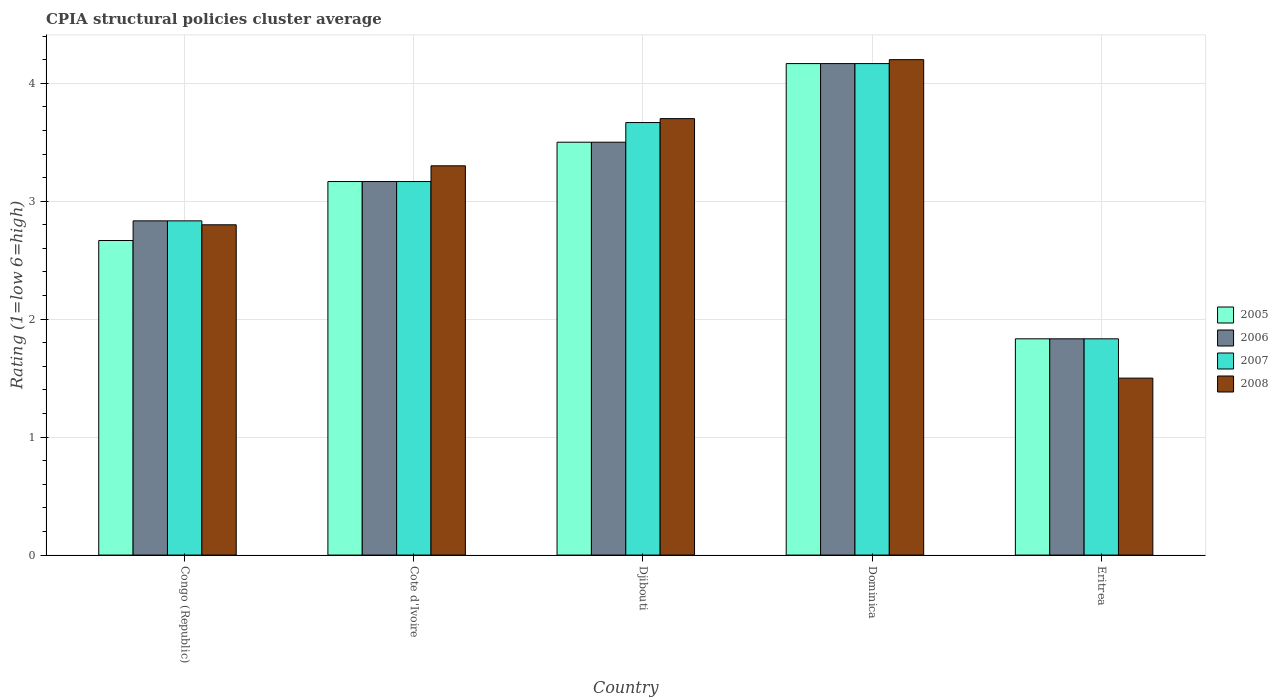How many different coloured bars are there?
Offer a very short reply. 4. Are the number of bars on each tick of the X-axis equal?
Provide a short and direct response. Yes. How many bars are there on the 4th tick from the right?
Offer a terse response. 4. What is the label of the 2nd group of bars from the left?
Your answer should be compact. Cote d'Ivoire. In how many cases, is the number of bars for a given country not equal to the number of legend labels?
Your answer should be very brief. 0. What is the CPIA rating in 2006 in Congo (Republic)?
Your response must be concise. 2.83. Across all countries, what is the minimum CPIA rating in 2006?
Your answer should be very brief. 1.83. In which country was the CPIA rating in 2008 maximum?
Provide a succinct answer. Dominica. In which country was the CPIA rating in 2005 minimum?
Keep it short and to the point. Eritrea. What is the total CPIA rating in 2007 in the graph?
Your response must be concise. 15.67. What is the difference between the CPIA rating in 2007 in Djibouti and that in Dominica?
Ensure brevity in your answer.  -0.5. What is the difference between the CPIA rating in 2006 in Dominica and the CPIA rating in 2005 in Djibouti?
Make the answer very short. 0.67. What is the average CPIA rating in 2008 per country?
Offer a very short reply. 3.1. What is the difference between the CPIA rating of/in 2007 and CPIA rating of/in 2008 in Congo (Republic)?
Ensure brevity in your answer.  0.03. In how many countries, is the CPIA rating in 2005 greater than 4.2?
Make the answer very short. 0. What is the ratio of the CPIA rating in 2008 in Cote d'Ivoire to that in Eritrea?
Keep it short and to the point. 2.2. Is the CPIA rating in 2007 in Congo (Republic) less than that in Djibouti?
Your response must be concise. Yes. What is the difference between the highest and the second highest CPIA rating in 2008?
Provide a short and direct response. -0.4. What is the difference between the highest and the lowest CPIA rating in 2006?
Give a very brief answer. 2.33. In how many countries, is the CPIA rating in 2008 greater than the average CPIA rating in 2008 taken over all countries?
Your response must be concise. 3. Is the sum of the CPIA rating in 2005 in Cote d'Ivoire and Djibouti greater than the maximum CPIA rating in 2006 across all countries?
Provide a succinct answer. Yes. Is it the case that in every country, the sum of the CPIA rating in 2007 and CPIA rating in 2005 is greater than the sum of CPIA rating in 2008 and CPIA rating in 2006?
Provide a short and direct response. No. How many bars are there?
Your answer should be compact. 20. How many countries are there in the graph?
Offer a very short reply. 5. Does the graph contain any zero values?
Keep it short and to the point. No. Does the graph contain grids?
Provide a succinct answer. Yes. What is the title of the graph?
Provide a short and direct response. CPIA structural policies cluster average. Does "2012" appear as one of the legend labels in the graph?
Provide a succinct answer. No. What is the label or title of the X-axis?
Your answer should be compact. Country. What is the label or title of the Y-axis?
Give a very brief answer. Rating (1=low 6=high). What is the Rating (1=low 6=high) in 2005 in Congo (Republic)?
Ensure brevity in your answer.  2.67. What is the Rating (1=low 6=high) in 2006 in Congo (Republic)?
Offer a very short reply. 2.83. What is the Rating (1=low 6=high) in 2007 in Congo (Republic)?
Make the answer very short. 2.83. What is the Rating (1=low 6=high) in 2008 in Congo (Republic)?
Your answer should be very brief. 2.8. What is the Rating (1=low 6=high) in 2005 in Cote d'Ivoire?
Offer a terse response. 3.17. What is the Rating (1=low 6=high) of 2006 in Cote d'Ivoire?
Provide a succinct answer. 3.17. What is the Rating (1=low 6=high) in 2007 in Cote d'Ivoire?
Your answer should be compact. 3.17. What is the Rating (1=low 6=high) in 2005 in Djibouti?
Ensure brevity in your answer.  3.5. What is the Rating (1=low 6=high) of 2006 in Djibouti?
Your response must be concise. 3.5. What is the Rating (1=low 6=high) in 2007 in Djibouti?
Offer a very short reply. 3.67. What is the Rating (1=low 6=high) in 2005 in Dominica?
Provide a short and direct response. 4.17. What is the Rating (1=low 6=high) in 2006 in Dominica?
Offer a terse response. 4.17. What is the Rating (1=low 6=high) of 2007 in Dominica?
Your response must be concise. 4.17. What is the Rating (1=low 6=high) in 2005 in Eritrea?
Your answer should be compact. 1.83. What is the Rating (1=low 6=high) of 2006 in Eritrea?
Your answer should be compact. 1.83. What is the Rating (1=low 6=high) of 2007 in Eritrea?
Ensure brevity in your answer.  1.83. Across all countries, what is the maximum Rating (1=low 6=high) of 2005?
Your response must be concise. 4.17. Across all countries, what is the maximum Rating (1=low 6=high) of 2006?
Provide a short and direct response. 4.17. Across all countries, what is the maximum Rating (1=low 6=high) in 2007?
Ensure brevity in your answer.  4.17. Across all countries, what is the maximum Rating (1=low 6=high) in 2008?
Provide a succinct answer. 4.2. Across all countries, what is the minimum Rating (1=low 6=high) of 2005?
Provide a short and direct response. 1.83. Across all countries, what is the minimum Rating (1=low 6=high) of 2006?
Your answer should be very brief. 1.83. Across all countries, what is the minimum Rating (1=low 6=high) in 2007?
Offer a very short reply. 1.83. What is the total Rating (1=low 6=high) of 2005 in the graph?
Your answer should be compact. 15.33. What is the total Rating (1=low 6=high) in 2006 in the graph?
Your response must be concise. 15.5. What is the total Rating (1=low 6=high) in 2007 in the graph?
Offer a terse response. 15.67. What is the difference between the Rating (1=low 6=high) in 2005 in Congo (Republic) and that in Cote d'Ivoire?
Your response must be concise. -0.5. What is the difference between the Rating (1=low 6=high) in 2006 in Congo (Republic) and that in Djibouti?
Your answer should be compact. -0.67. What is the difference between the Rating (1=low 6=high) of 2008 in Congo (Republic) and that in Djibouti?
Keep it short and to the point. -0.9. What is the difference between the Rating (1=low 6=high) in 2005 in Congo (Republic) and that in Dominica?
Keep it short and to the point. -1.5. What is the difference between the Rating (1=low 6=high) in 2006 in Congo (Republic) and that in Dominica?
Provide a succinct answer. -1.33. What is the difference between the Rating (1=low 6=high) in 2007 in Congo (Republic) and that in Dominica?
Offer a very short reply. -1.33. What is the difference between the Rating (1=low 6=high) in 2005 in Congo (Republic) and that in Eritrea?
Offer a very short reply. 0.83. What is the difference between the Rating (1=low 6=high) in 2006 in Congo (Republic) and that in Eritrea?
Your answer should be compact. 1. What is the difference between the Rating (1=low 6=high) in 2005 in Cote d'Ivoire and that in Dominica?
Provide a short and direct response. -1. What is the difference between the Rating (1=low 6=high) in 2005 in Cote d'Ivoire and that in Eritrea?
Offer a very short reply. 1.33. What is the difference between the Rating (1=low 6=high) of 2006 in Cote d'Ivoire and that in Eritrea?
Provide a succinct answer. 1.33. What is the difference between the Rating (1=low 6=high) in 2008 in Cote d'Ivoire and that in Eritrea?
Ensure brevity in your answer.  1.8. What is the difference between the Rating (1=low 6=high) in 2007 in Djibouti and that in Dominica?
Ensure brevity in your answer.  -0.5. What is the difference between the Rating (1=low 6=high) in 2007 in Djibouti and that in Eritrea?
Make the answer very short. 1.83. What is the difference between the Rating (1=low 6=high) in 2005 in Dominica and that in Eritrea?
Your answer should be compact. 2.33. What is the difference between the Rating (1=low 6=high) in 2006 in Dominica and that in Eritrea?
Your answer should be compact. 2.33. What is the difference between the Rating (1=low 6=high) in 2007 in Dominica and that in Eritrea?
Offer a terse response. 2.33. What is the difference between the Rating (1=low 6=high) in 2008 in Dominica and that in Eritrea?
Your answer should be very brief. 2.7. What is the difference between the Rating (1=low 6=high) of 2005 in Congo (Republic) and the Rating (1=low 6=high) of 2006 in Cote d'Ivoire?
Provide a succinct answer. -0.5. What is the difference between the Rating (1=low 6=high) of 2005 in Congo (Republic) and the Rating (1=low 6=high) of 2007 in Cote d'Ivoire?
Give a very brief answer. -0.5. What is the difference between the Rating (1=low 6=high) in 2005 in Congo (Republic) and the Rating (1=low 6=high) in 2008 in Cote d'Ivoire?
Your response must be concise. -0.63. What is the difference between the Rating (1=low 6=high) of 2006 in Congo (Republic) and the Rating (1=low 6=high) of 2008 in Cote d'Ivoire?
Keep it short and to the point. -0.47. What is the difference between the Rating (1=low 6=high) of 2007 in Congo (Republic) and the Rating (1=low 6=high) of 2008 in Cote d'Ivoire?
Offer a very short reply. -0.47. What is the difference between the Rating (1=low 6=high) of 2005 in Congo (Republic) and the Rating (1=low 6=high) of 2006 in Djibouti?
Offer a very short reply. -0.83. What is the difference between the Rating (1=low 6=high) in 2005 in Congo (Republic) and the Rating (1=low 6=high) in 2008 in Djibouti?
Make the answer very short. -1.03. What is the difference between the Rating (1=low 6=high) in 2006 in Congo (Republic) and the Rating (1=low 6=high) in 2007 in Djibouti?
Ensure brevity in your answer.  -0.83. What is the difference between the Rating (1=low 6=high) in 2006 in Congo (Republic) and the Rating (1=low 6=high) in 2008 in Djibouti?
Give a very brief answer. -0.87. What is the difference between the Rating (1=low 6=high) in 2007 in Congo (Republic) and the Rating (1=low 6=high) in 2008 in Djibouti?
Give a very brief answer. -0.87. What is the difference between the Rating (1=low 6=high) in 2005 in Congo (Republic) and the Rating (1=low 6=high) in 2006 in Dominica?
Your response must be concise. -1.5. What is the difference between the Rating (1=low 6=high) in 2005 in Congo (Republic) and the Rating (1=low 6=high) in 2007 in Dominica?
Offer a very short reply. -1.5. What is the difference between the Rating (1=low 6=high) in 2005 in Congo (Republic) and the Rating (1=low 6=high) in 2008 in Dominica?
Provide a succinct answer. -1.53. What is the difference between the Rating (1=low 6=high) of 2006 in Congo (Republic) and the Rating (1=low 6=high) of 2007 in Dominica?
Offer a terse response. -1.33. What is the difference between the Rating (1=low 6=high) of 2006 in Congo (Republic) and the Rating (1=low 6=high) of 2008 in Dominica?
Ensure brevity in your answer.  -1.37. What is the difference between the Rating (1=low 6=high) of 2007 in Congo (Republic) and the Rating (1=low 6=high) of 2008 in Dominica?
Offer a very short reply. -1.37. What is the difference between the Rating (1=low 6=high) in 2005 in Congo (Republic) and the Rating (1=low 6=high) in 2007 in Eritrea?
Your response must be concise. 0.83. What is the difference between the Rating (1=low 6=high) of 2005 in Congo (Republic) and the Rating (1=low 6=high) of 2008 in Eritrea?
Keep it short and to the point. 1.17. What is the difference between the Rating (1=low 6=high) in 2006 in Congo (Republic) and the Rating (1=low 6=high) in 2008 in Eritrea?
Keep it short and to the point. 1.33. What is the difference between the Rating (1=low 6=high) in 2007 in Congo (Republic) and the Rating (1=low 6=high) in 2008 in Eritrea?
Give a very brief answer. 1.33. What is the difference between the Rating (1=low 6=high) in 2005 in Cote d'Ivoire and the Rating (1=low 6=high) in 2007 in Djibouti?
Ensure brevity in your answer.  -0.5. What is the difference between the Rating (1=low 6=high) of 2005 in Cote d'Ivoire and the Rating (1=low 6=high) of 2008 in Djibouti?
Offer a very short reply. -0.53. What is the difference between the Rating (1=low 6=high) of 2006 in Cote d'Ivoire and the Rating (1=low 6=high) of 2007 in Djibouti?
Keep it short and to the point. -0.5. What is the difference between the Rating (1=low 6=high) in 2006 in Cote d'Ivoire and the Rating (1=low 6=high) in 2008 in Djibouti?
Make the answer very short. -0.53. What is the difference between the Rating (1=low 6=high) in 2007 in Cote d'Ivoire and the Rating (1=low 6=high) in 2008 in Djibouti?
Your response must be concise. -0.53. What is the difference between the Rating (1=low 6=high) of 2005 in Cote d'Ivoire and the Rating (1=low 6=high) of 2007 in Dominica?
Your response must be concise. -1. What is the difference between the Rating (1=low 6=high) in 2005 in Cote d'Ivoire and the Rating (1=low 6=high) in 2008 in Dominica?
Make the answer very short. -1.03. What is the difference between the Rating (1=low 6=high) of 2006 in Cote d'Ivoire and the Rating (1=low 6=high) of 2007 in Dominica?
Offer a terse response. -1. What is the difference between the Rating (1=low 6=high) in 2006 in Cote d'Ivoire and the Rating (1=low 6=high) in 2008 in Dominica?
Provide a short and direct response. -1.03. What is the difference between the Rating (1=low 6=high) in 2007 in Cote d'Ivoire and the Rating (1=low 6=high) in 2008 in Dominica?
Offer a terse response. -1.03. What is the difference between the Rating (1=low 6=high) in 2005 in Cote d'Ivoire and the Rating (1=low 6=high) in 2008 in Eritrea?
Your response must be concise. 1.67. What is the difference between the Rating (1=low 6=high) in 2006 in Cote d'Ivoire and the Rating (1=low 6=high) in 2008 in Eritrea?
Give a very brief answer. 1.67. What is the difference between the Rating (1=low 6=high) of 2005 in Djibouti and the Rating (1=low 6=high) of 2006 in Dominica?
Give a very brief answer. -0.67. What is the difference between the Rating (1=low 6=high) in 2005 in Djibouti and the Rating (1=low 6=high) in 2007 in Dominica?
Make the answer very short. -0.67. What is the difference between the Rating (1=low 6=high) in 2005 in Djibouti and the Rating (1=low 6=high) in 2008 in Dominica?
Provide a short and direct response. -0.7. What is the difference between the Rating (1=low 6=high) of 2006 in Djibouti and the Rating (1=low 6=high) of 2007 in Dominica?
Give a very brief answer. -0.67. What is the difference between the Rating (1=low 6=high) in 2007 in Djibouti and the Rating (1=low 6=high) in 2008 in Dominica?
Give a very brief answer. -0.53. What is the difference between the Rating (1=low 6=high) of 2005 in Djibouti and the Rating (1=low 6=high) of 2007 in Eritrea?
Offer a terse response. 1.67. What is the difference between the Rating (1=low 6=high) in 2006 in Djibouti and the Rating (1=low 6=high) in 2007 in Eritrea?
Provide a short and direct response. 1.67. What is the difference between the Rating (1=low 6=high) of 2006 in Djibouti and the Rating (1=low 6=high) of 2008 in Eritrea?
Ensure brevity in your answer.  2. What is the difference between the Rating (1=low 6=high) of 2007 in Djibouti and the Rating (1=low 6=high) of 2008 in Eritrea?
Provide a succinct answer. 2.17. What is the difference between the Rating (1=low 6=high) in 2005 in Dominica and the Rating (1=low 6=high) in 2006 in Eritrea?
Offer a very short reply. 2.33. What is the difference between the Rating (1=low 6=high) of 2005 in Dominica and the Rating (1=low 6=high) of 2007 in Eritrea?
Ensure brevity in your answer.  2.33. What is the difference between the Rating (1=low 6=high) of 2005 in Dominica and the Rating (1=low 6=high) of 2008 in Eritrea?
Give a very brief answer. 2.67. What is the difference between the Rating (1=low 6=high) of 2006 in Dominica and the Rating (1=low 6=high) of 2007 in Eritrea?
Offer a very short reply. 2.33. What is the difference between the Rating (1=low 6=high) of 2006 in Dominica and the Rating (1=low 6=high) of 2008 in Eritrea?
Offer a very short reply. 2.67. What is the difference between the Rating (1=low 6=high) in 2007 in Dominica and the Rating (1=low 6=high) in 2008 in Eritrea?
Ensure brevity in your answer.  2.67. What is the average Rating (1=low 6=high) of 2005 per country?
Offer a very short reply. 3.07. What is the average Rating (1=low 6=high) in 2006 per country?
Keep it short and to the point. 3.1. What is the average Rating (1=low 6=high) in 2007 per country?
Keep it short and to the point. 3.13. What is the difference between the Rating (1=low 6=high) in 2005 and Rating (1=low 6=high) in 2006 in Congo (Republic)?
Make the answer very short. -0.17. What is the difference between the Rating (1=low 6=high) in 2005 and Rating (1=low 6=high) in 2007 in Congo (Republic)?
Your answer should be compact. -0.17. What is the difference between the Rating (1=low 6=high) in 2005 and Rating (1=low 6=high) in 2008 in Congo (Republic)?
Your response must be concise. -0.13. What is the difference between the Rating (1=low 6=high) in 2006 and Rating (1=low 6=high) in 2008 in Congo (Republic)?
Your response must be concise. 0.03. What is the difference between the Rating (1=low 6=high) of 2005 and Rating (1=low 6=high) of 2006 in Cote d'Ivoire?
Your answer should be very brief. 0. What is the difference between the Rating (1=low 6=high) in 2005 and Rating (1=low 6=high) in 2007 in Cote d'Ivoire?
Provide a short and direct response. 0. What is the difference between the Rating (1=low 6=high) in 2005 and Rating (1=low 6=high) in 2008 in Cote d'Ivoire?
Your response must be concise. -0.13. What is the difference between the Rating (1=low 6=high) in 2006 and Rating (1=low 6=high) in 2008 in Cote d'Ivoire?
Provide a succinct answer. -0.13. What is the difference between the Rating (1=low 6=high) in 2007 and Rating (1=low 6=high) in 2008 in Cote d'Ivoire?
Provide a succinct answer. -0.13. What is the difference between the Rating (1=low 6=high) of 2005 and Rating (1=low 6=high) of 2007 in Djibouti?
Make the answer very short. -0.17. What is the difference between the Rating (1=low 6=high) in 2005 and Rating (1=low 6=high) in 2008 in Djibouti?
Offer a very short reply. -0.2. What is the difference between the Rating (1=low 6=high) in 2006 and Rating (1=low 6=high) in 2007 in Djibouti?
Provide a short and direct response. -0.17. What is the difference between the Rating (1=low 6=high) of 2007 and Rating (1=low 6=high) of 2008 in Djibouti?
Provide a succinct answer. -0.03. What is the difference between the Rating (1=low 6=high) in 2005 and Rating (1=low 6=high) in 2006 in Dominica?
Provide a short and direct response. 0. What is the difference between the Rating (1=low 6=high) of 2005 and Rating (1=low 6=high) of 2008 in Dominica?
Keep it short and to the point. -0.03. What is the difference between the Rating (1=low 6=high) in 2006 and Rating (1=low 6=high) in 2008 in Dominica?
Your answer should be compact. -0.03. What is the difference between the Rating (1=low 6=high) in 2007 and Rating (1=low 6=high) in 2008 in Dominica?
Your answer should be compact. -0.03. What is the difference between the Rating (1=low 6=high) in 2007 and Rating (1=low 6=high) in 2008 in Eritrea?
Offer a very short reply. 0.33. What is the ratio of the Rating (1=low 6=high) in 2005 in Congo (Republic) to that in Cote d'Ivoire?
Ensure brevity in your answer.  0.84. What is the ratio of the Rating (1=low 6=high) in 2006 in Congo (Republic) to that in Cote d'Ivoire?
Offer a terse response. 0.89. What is the ratio of the Rating (1=low 6=high) of 2007 in Congo (Republic) to that in Cote d'Ivoire?
Provide a succinct answer. 0.89. What is the ratio of the Rating (1=low 6=high) of 2008 in Congo (Republic) to that in Cote d'Ivoire?
Your answer should be compact. 0.85. What is the ratio of the Rating (1=low 6=high) of 2005 in Congo (Republic) to that in Djibouti?
Your answer should be very brief. 0.76. What is the ratio of the Rating (1=low 6=high) of 2006 in Congo (Republic) to that in Djibouti?
Give a very brief answer. 0.81. What is the ratio of the Rating (1=low 6=high) in 2007 in Congo (Republic) to that in Djibouti?
Offer a very short reply. 0.77. What is the ratio of the Rating (1=low 6=high) in 2008 in Congo (Republic) to that in Djibouti?
Provide a succinct answer. 0.76. What is the ratio of the Rating (1=low 6=high) of 2005 in Congo (Republic) to that in Dominica?
Keep it short and to the point. 0.64. What is the ratio of the Rating (1=low 6=high) in 2006 in Congo (Republic) to that in Dominica?
Offer a terse response. 0.68. What is the ratio of the Rating (1=low 6=high) of 2007 in Congo (Republic) to that in Dominica?
Your answer should be compact. 0.68. What is the ratio of the Rating (1=low 6=high) in 2005 in Congo (Republic) to that in Eritrea?
Your answer should be very brief. 1.45. What is the ratio of the Rating (1=low 6=high) in 2006 in Congo (Republic) to that in Eritrea?
Provide a succinct answer. 1.55. What is the ratio of the Rating (1=low 6=high) in 2007 in Congo (Republic) to that in Eritrea?
Your answer should be compact. 1.55. What is the ratio of the Rating (1=low 6=high) in 2008 in Congo (Republic) to that in Eritrea?
Your answer should be very brief. 1.87. What is the ratio of the Rating (1=low 6=high) of 2005 in Cote d'Ivoire to that in Djibouti?
Offer a very short reply. 0.9. What is the ratio of the Rating (1=low 6=high) in 2006 in Cote d'Ivoire to that in Djibouti?
Offer a very short reply. 0.9. What is the ratio of the Rating (1=low 6=high) of 2007 in Cote d'Ivoire to that in Djibouti?
Make the answer very short. 0.86. What is the ratio of the Rating (1=low 6=high) of 2008 in Cote d'Ivoire to that in Djibouti?
Keep it short and to the point. 0.89. What is the ratio of the Rating (1=low 6=high) in 2005 in Cote d'Ivoire to that in Dominica?
Give a very brief answer. 0.76. What is the ratio of the Rating (1=low 6=high) of 2006 in Cote d'Ivoire to that in Dominica?
Provide a short and direct response. 0.76. What is the ratio of the Rating (1=low 6=high) in 2007 in Cote d'Ivoire to that in Dominica?
Offer a terse response. 0.76. What is the ratio of the Rating (1=low 6=high) in 2008 in Cote d'Ivoire to that in Dominica?
Provide a succinct answer. 0.79. What is the ratio of the Rating (1=low 6=high) of 2005 in Cote d'Ivoire to that in Eritrea?
Offer a very short reply. 1.73. What is the ratio of the Rating (1=low 6=high) in 2006 in Cote d'Ivoire to that in Eritrea?
Your answer should be very brief. 1.73. What is the ratio of the Rating (1=low 6=high) in 2007 in Cote d'Ivoire to that in Eritrea?
Give a very brief answer. 1.73. What is the ratio of the Rating (1=low 6=high) in 2005 in Djibouti to that in Dominica?
Keep it short and to the point. 0.84. What is the ratio of the Rating (1=low 6=high) in 2006 in Djibouti to that in Dominica?
Make the answer very short. 0.84. What is the ratio of the Rating (1=low 6=high) of 2007 in Djibouti to that in Dominica?
Your response must be concise. 0.88. What is the ratio of the Rating (1=low 6=high) in 2008 in Djibouti to that in Dominica?
Make the answer very short. 0.88. What is the ratio of the Rating (1=low 6=high) of 2005 in Djibouti to that in Eritrea?
Provide a succinct answer. 1.91. What is the ratio of the Rating (1=low 6=high) of 2006 in Djibouti to that in Eritrea?
Offer a very short reply. 1.91. What is the ratio of the Rating (1=low 6=high) of 2007 in Djibouti to that in Eritrea?
Keep it short and to the point. 2. What is the ratio of the Rating (1=low 6=high) in 2008 in Djibouti to that in Eritrea?
Keep it short and to the point. 2.47. What is the ratio of the Rating (1=low 6=high) of 2005 in Dominica to that in Eritrea?
Provide a short and direct response. 2.27. What is the ratio of the Rating (1=low 6=high) of 2006 in Dominica to that in Eritrea?
Make the answer very short. 2.27. What is the ratio of the Rating (1=low 6=high) of 2007 in Dominica to that in Eritrea?
Your response must be concise. 2.27. What is the ratio of the Rating (1=low 6=high) of 2008 in Dominica to that in Eritrea?
Make the answer very short. 2.8. What is the difference between the highest and the second highest Rating (1=low 6=high) of 2007?
Offer a terse response. 0.5. What is the difference between the highest and the lowest Rating (1=low 6=high) in 2005?
Your answer should be compact. 2.33. What is the difference between the highest and the lowest Rating (1=low 6=high) in 2006?
Your answer should be compact. 2.33. What is the difference between the highest and the lowest Rating (1=low 6=high) in 2007?
Your response must be concise. 2.33. What is the difference between the highest and the lowest Rating (1=low 6=high) in 2008?
Provide a succinct answer. 2.7. 